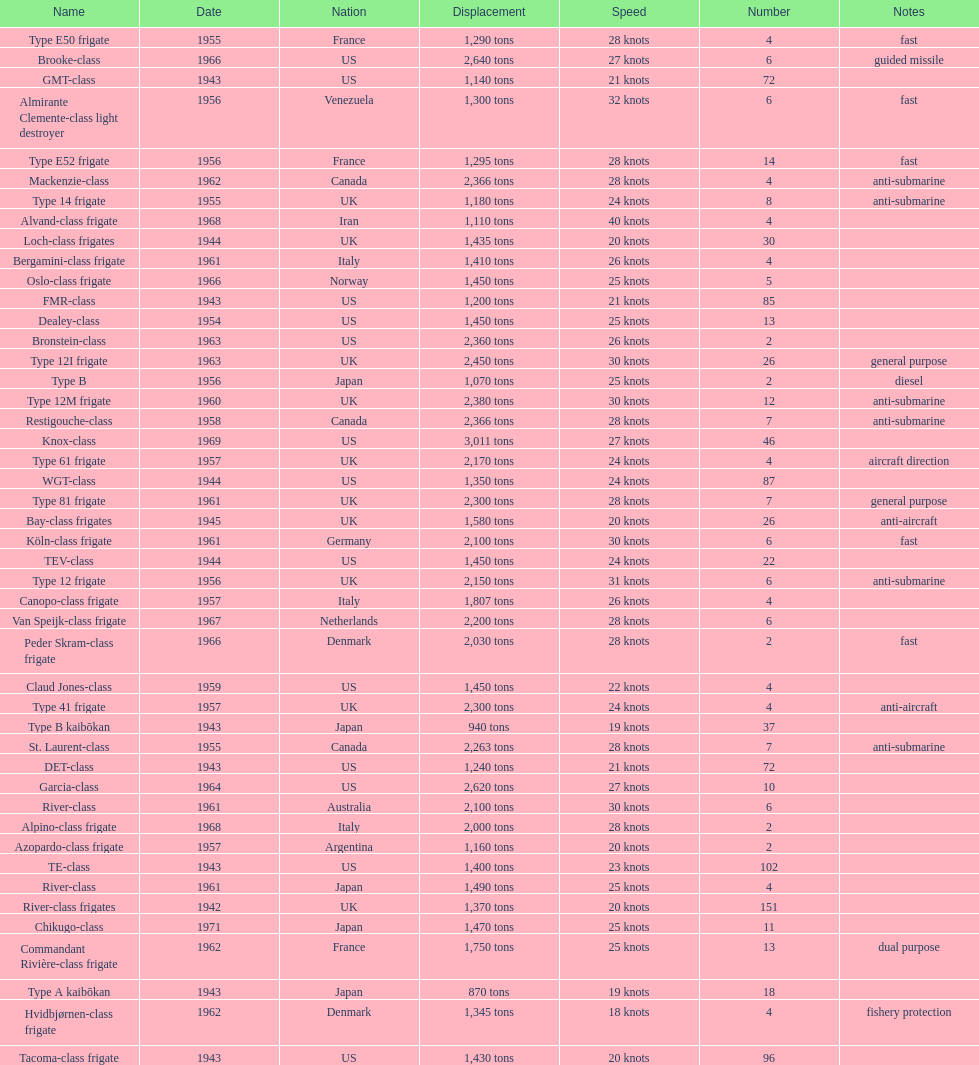How many consecutive escorts were in 1943? 7. 